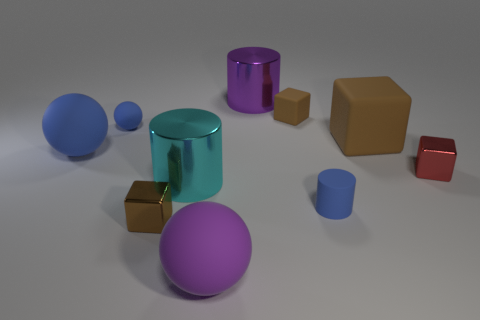The tiny block that is both in front of the small blue sphere and on the left side of the red metallic cube is what color?
Your answer should be very brief. Brown. How many brown objects are in front of the small brown object behind the large brown matte thing?
Make the answer very short. 2. Are there any other brown things of the same shape as the large brown rubber thing?
Keep it short and to the point. Yes. Does the large brown object right of the purple metal cylinder have the same shape as the big metal object that is behind the large blue rubber ball?
Offer a very short reply. No. How many objects are cyan metallic objects or brown balls?
Your response must be concise. 1. What is the size of the brown metallic object that is the same shape as the small red metallic object?
Give a very brief answer. Small. Is the number of tiny blocks right of the purple rubber object greater than the number of cyan cubes?
Offer a terse response. Yes. Does the tiny red object have the same material as the large block?
Offer a very short reply. No. What number of objects are either big cylinders behind the big brown rubber block or matte spheres that are behind the small red block?
Make the answer very short. 3. The other large shiny thing that is the same shape as the cyan shiny object is what color?
Make the answer very short. Purple. 